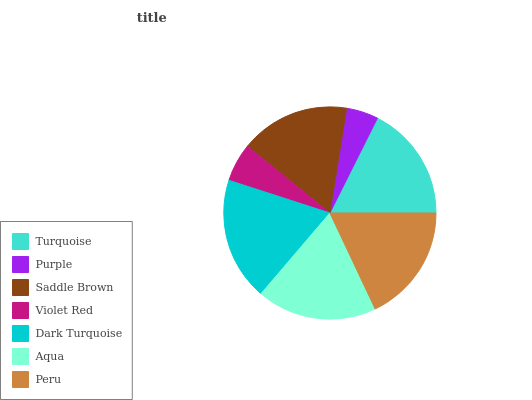Is Purple the minimum?
Answer yes or no. Yes. Is Dark Turquoise the maximum?
Answer yes or no. Yes. Is Saddle Brown the minimum?
Answer yes or no. No. Is Saddle Brown the maximum?
Answer yes or no. No. Is Saddle Brown greater than Purple?
Answer yes or no. Yes. Is Purple less than Saddle Brown?
Answer yes or no. Yes. Is Purple greater than Saddle Brown?
Answer yes or no. No. Is Saddle Brown less than Purple?
Answer yes or no. No. Is Turquoise the high median?
Answer yes or no. Yes. Is Turquoise the low median?
Answer yes or no. Yes. Is Saddle Brown the high median?
Answer yes or no. No. Is Peru the low median?
Answer yes or no. No. 